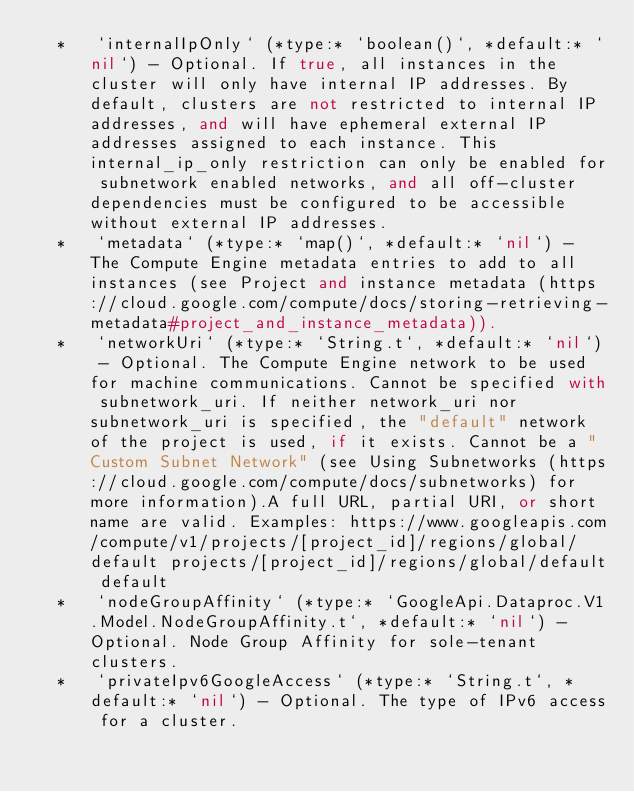Convert code to text. <code><loc_0><loc_0><loc_500><loc_500><_Elixir_>  *   `internalIpOnly` (*type:* `boolean()`, *default:* `nil`) - Optional. If true, all instances in the cluster will only have internal IP addresses. By default, clusters are not restricted to internal IP addresses, and will have ephemeral external IP addresses assigned to each instance. This internal_ip_only restriction can only be enabled for subnetwork enabled networks, and all off-cluster dependencies must be configured to be accessible without external IP addresses.
  *   `metadata` (*type:* `map()`, *default:* `nil`) - The Compute Engine metadata entries to add to all instances (see Project and instance metadata (https://cloud.google.com/compute/docs/storing-retrieving-metadata#project_and_instance_metadata)).
  *   `networkUri` (*type:* `String.t`, *default:* `nil`) - Optional. The Compute Engine network to be used for machine communications. Cannot be specified with subnetwork_uri. If neither network_uri nor subnetwork_uri is specified, the "default" network of the project is used, if it exists. Cannot be a "Custom Subnet Network" (see Using Subnetworks (https://cloud.google.com/compute/docs/subnetworks) for more information).A full URL, partial URI, or short name are valid. Examples: https://www.googleapis.com/compute/v1/projects/[project_id]/regions/global/default projects/[project_id]/regions/global/default default
  *   `nodeGroupAffinity` (*type:* `GoogleApi.Dataproc.V1.Model.NodeGroupAffinity.t`, *default:* `nil`) - Optional. Node Group Affinity for sole-tenant clusters.
  *   `privateIpv6GoogleAccess` (*type:* `String.t`, *default:* `nil`) - Optional. The type of IPv6 access for a cluster.</code> 